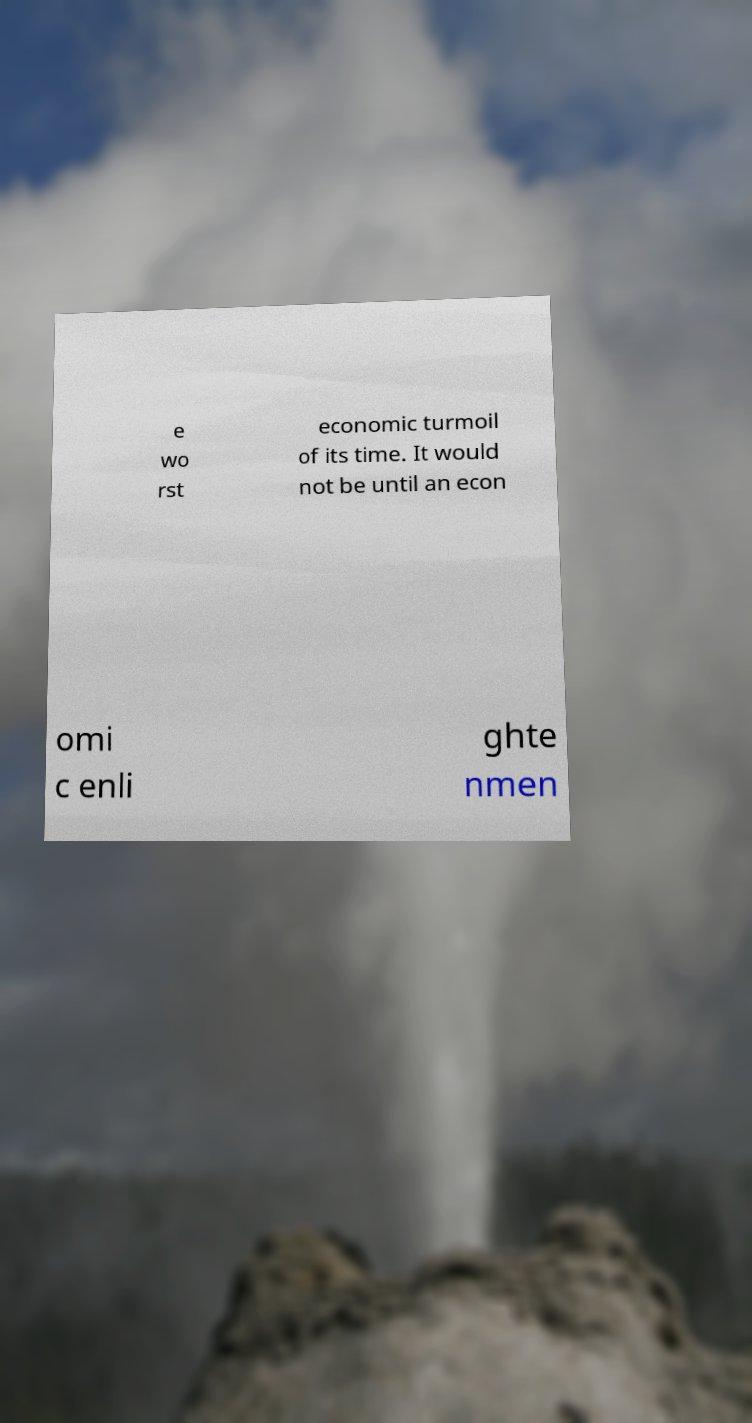Can you accurately transcribe the text from the provided image for me? e wo rst economic turmoil of its time. It would not be until an econ omi c enli ghte nmen 